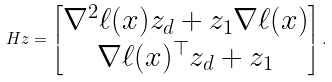Convert formula to latex. <formula><loc_0><loc_0><loc_500><loc_500>H z = \begin{bmatrix} \nabla ^ { 2 } \ell ( x ) z _ { d } + z _ { 1 } \nabla \ell ( x ) \\ \nabla \ell ( x ) ^ { \top } z _ { d } + z _ { 1 } \end{bmatrix} .</formula> 